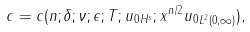Convert formula to latex. <formula><loc_0><loc_0><loc_500><loc_500>c = c ( n ; \delta ; \nu ; \epsilon ; T ; \| u _ { 0 } \| _ { H ^ { s } } ; \| x ^ { n / 2 } u _ { 0 } \| _ { L ^ { 2 } ( 0 , \infty ) } ) ,</formula> 